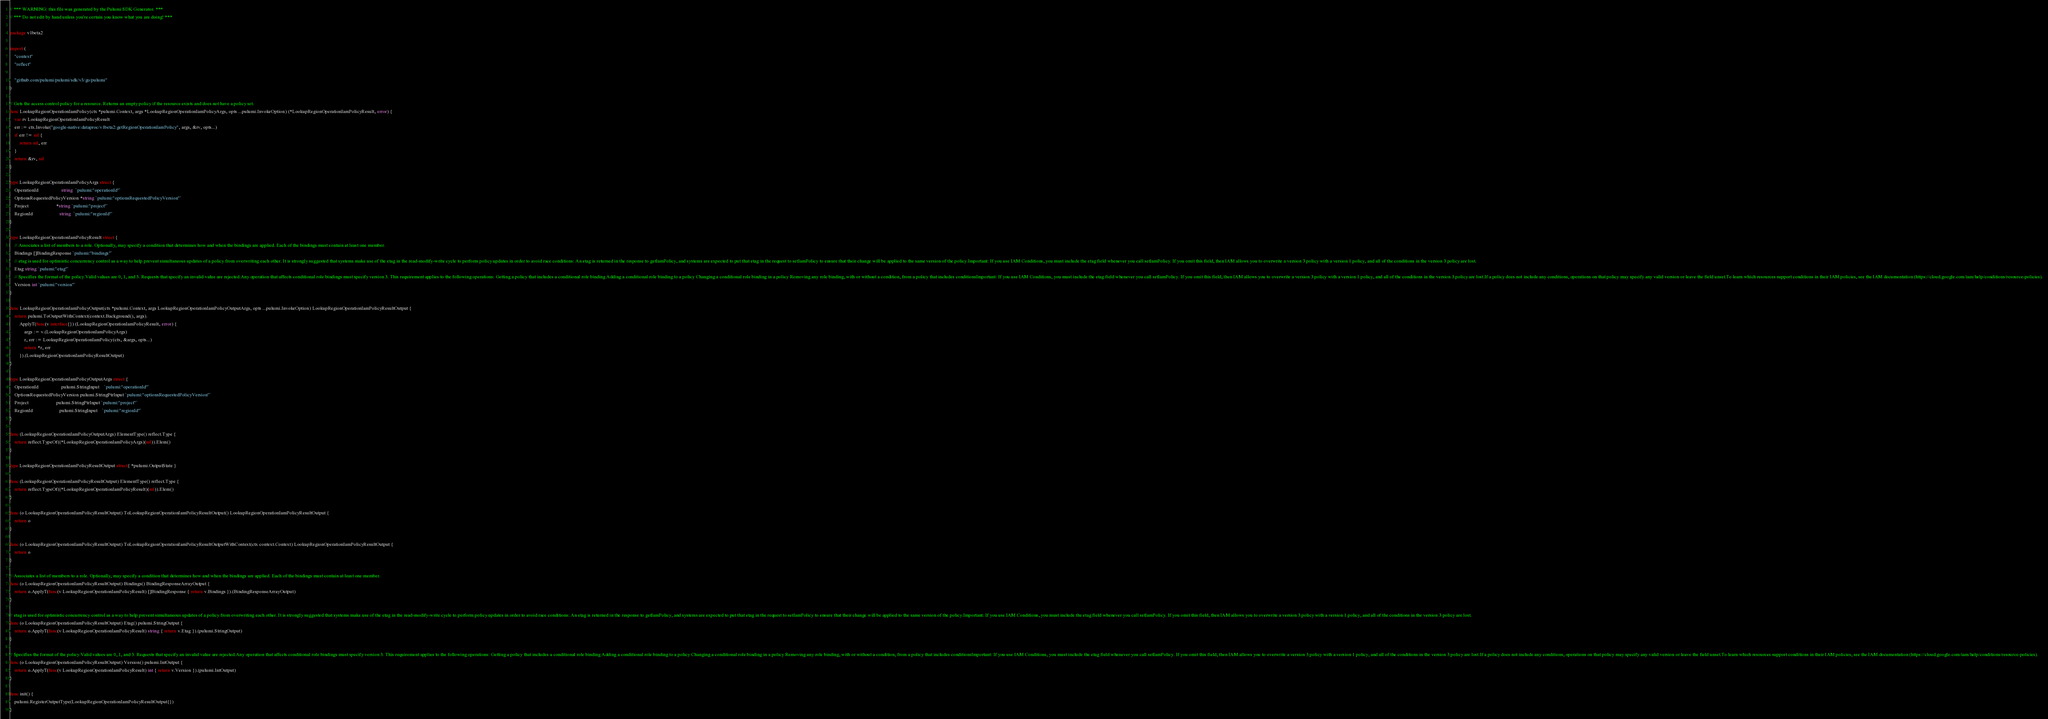Convert code to text. <code><loc_0><loc_0><loc_500><loc_500><_Go_>// *** WARNING: this file was generated by the Pulumi SDK Generator. ***
// *** Do not edit by hand unless you're certain you know what you are doing! ***

package v1beta2

import (
	"context"
	"reflect"

	"github.com/pulumi/pulumi/sdk/v3/go/pulumi"
)

// Gets the access control policy for a resource. Returns an empty policy if the resource exists and does not have a policy set.
func LookupRegionOperationIamPolicy(ctx *pulumi.Context, args *LookupRegionOperationIamPolicyArgs, opts ...pulumi.InvokeOption) (*LookupRegionOperationIamPolicyResult, error) {
	var rv LookupRegionOperationIamPolicyResult
	err := ctx.Invoke("google-native:dataproc/v1beta2:getRegionOperationIamPolicy", args, &rv, opts...)
	if err != nil {
		return nil, err
	}
	return &rv, nil
}

type LookupRegionOperationIamPolicyArgs struct {
	OperationId                   string  `pulumi:"operationId"`
	OptionsRequestedPolicyVersion *string `pulumi:"optionsRequestedPolicyVersion"`
	Project                       *string `pulumi:"project"`
	RegionId                      string  `pulumi:"regionId"`
}

type LookupRegionOperationIamPolicyResult struct {
	// Associates a list of members to a role. Optionally, may specify a condition that determines how and when the bindings are applied. Each of the bindings must contain at least one member.
	Bindings []BindingResponse `pulumi:"bindings"`
	// etag is used for optimistic concurrency control as a way to help prevent simultaneous updates of a policy from overwriting each other. It is strongly suggested that systems make use of the etag in the read-modify-write cycle to perform policy updates in order to avoid race conditions: An etag is returned in the response to getIamPolicy, and systems are expected to put that etag in the request to setIamPolicy to ensure that their change will be applied to the same version of the policy.Important: If you use IAM Conditions, you must include the etag field whenever you call setIamPolicy. If you omit this field, then IAM allows you to overwrite a version 3 policy with a version 1 policy, and all of the conditions in the version 3 policy are lost.
	Etag string `pulumi:"etag"`
	// Specifies the format of the policy.Valid values are 0, 1, and 3. Requests that specify an invalid value are rejected.Any operation that affects conditional role bindings must specify version 3. This requirement applies to the following operations: Getting a policy that includes a conditional role binding Adding a conditional role binding to a policy Changing a conditional role binding in a policy Removing any role binding, with or without a condition, from a policy that includes conditionsImportant: If you use IAM Conditions, you must include the etag field whenever you call setIamPolicy. If you omit this field, then IAM allows you to overwrite a version 3 policy with a version 1 policy, and all of the conditions in the version 3 policy are lost.If a policy does not include any conditions, operations on that policy may specify any valid version or leave the field unset.To learn which resources support conditions in their IAM policies, see the IAM documentation (https://cloud.google.com/iam/help/conditions/resource-policies).
	Version int `pulumi:"version"`
}

func LookupRegionOperationIamPolicyOutput(ctx *pulumi.Context, args LookupRegionOperationIamPolicyOutputArgs, opts ...pulumi.InvokeOption) LookupRegionOperationIamPolicyResultOutput {
	return pulumi.ToOutputWithContext(context.Background(), args).
		ApplyT(func(v interface{}) (LookupRegionOperationIamPolicyResult, error) {
			args := v.(LookupRegionOperationIamPolicyArgs)
			r, err := LookupRegionOperationIamPolicy(ctx, &args, opts...)
			return *r, err
		}).(LookupRegionOperationIamPolicyResultOutput)
}

type LookupRegionOperationIamPolicyOutputArgs struct {
	OperationId                   pulumi.StringInput    `pulumi:"operationId"`
	OptionsRequestedPolicyVersion pulumi.StringPtrInput `pulumi:"optionsRequestedPolicyVersion"`
	Project                       pulumi.StringPtrInput `pulumi:"project"`
	RegionId                      pulumi.StringInput    `pulumi:"regionId"`
}

func (LookupRegionOperationIamPolicyOutputArgs) ElementType() reflect.Type {
	return reflect.TypeOf((*LookupRegionOperationIamPolicyArgs)(nil)).Elem()
}

type LookupRegionOperationIamPolicyResultOutput struct{ *pulumi.OutputState }

func (LookupRegionOperationIamPolicyResultOutput) ElementType() reflect.Type {
	return reflect.TypeOf((*LookupRegionOperationIamPolicyResult)(nil)).Elem()
}

func (o LookupRegionOperationIamPolicyResultOutput) ToLookupRegionOperationIamPolicyResultOutput() LookupRegionOperationIamPolicyResultOutput {
	return o
}

func (o LookupRegionOperationIamPolicyResultOutput) ToLookupRegionOperationIamPolicyResultOutputWithContext(ctx context.Context) LookupRegionOperationIamPolicyResultOutput {
	return o
}

// Associates a list of members to a role. Optionally, may specify a condition that determines how and when the bindings are applied. Each of the bindings must contain at least one member.
func (o LookupRegionOperationIamPolicyResultOutput) Bindings() BindingResponseArrayOutput {
	return o.ApplyT(func(v LookupRegionOperationIamPolicyResult) []BindingResponse { return v.Bindings }).(BindingResponseArrayOutput)
}

// etag is used for optimistic concurrency control as a way to help prevent simultaneous updates of a policy from overwriting each other. It is strongly suggested that systems make use of the etag in the read-modify-write cycle to perform policy updates in order to avoid race conditions: An etag is returned in the response to getIamPolicy, and systems are expected to put that etag in the request to setIamPolicy to ensure that their change will be applied to the same version of the policy.Important: If you use IAM Conditions, you must include the etag field whenever you call setIamPolicy. If you omit this field, then IAM allows you to overwrite a version 3 policy with a version 1 policy, and all of the conditions in the version 3 policy are lost.
func (o LookupRegionOperationIamPolicyResultOutput) Etag() pulumi.StringOutput {
	return o.ApplyT(func(v LookupRegionOperationIamPolicyResult) string { return v.Etag }).(pulumi.StringOutput)
}

// Specifies the format of the policy.Valid values are 0, 1, and 3. Requests that specify an invalid value are rejected.Any operation that affects conditional role bindings must specify version 3. This requirement applies to the following operations: Getting a policy that includes a conditional role binding Adding a conditional role binding to a policy Changing a conditional role binding in a policy Removing any role binding, with or without a condition, from a policy that includes conditionsImportant: If you use IAM Conditions, you must include the etag field whenever you call setIamPolicy. If you omit this field, then IAM allows you to overwrite a version 3 policy with a version 1 policy, and all of the conditions in the version 3 policy are lost.If a policy does not include any conditions, operations on that policy may specify any valid version or leave the field unset.To learn which resources support conditions in their IAM policies, see the IAM documentation (https://cloud.google.com/iam/help/conditions/resource-policies).
func (o LookupRegionOperationIamPolicyResultOutput) Version() pulumi.IntOutput {
	return o.ApplyT(func(v LookupRegionOperationIamPolicyResult) int { return v.Version }).(pulumi.IntOutput)
}

func init() {
	pulumi.RegisterOutputType(LookupRegionOperationIamPolicyResultOutput{})
}
</code> 